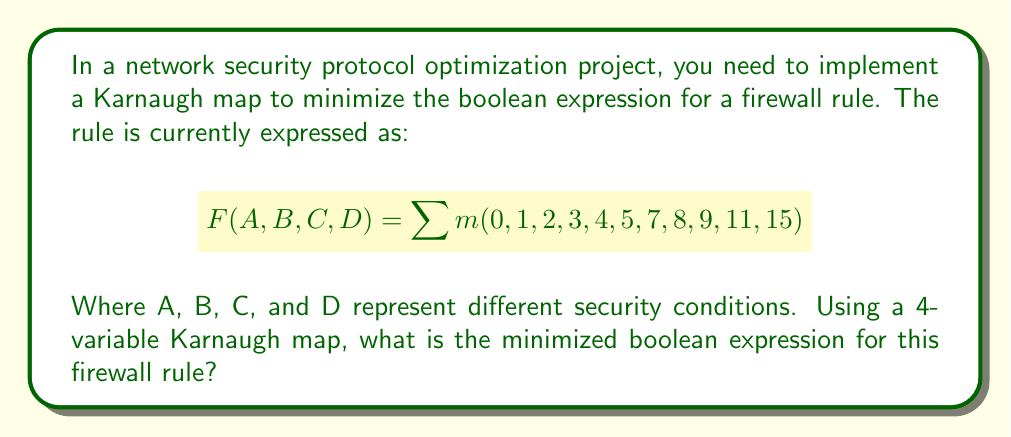Provide a solution to this math problem. Let's approach this step-by-step:

1) First, we need to create a 4-variable Karnaugh map:

[asy]
unitsize(1cm);
for(int i=0; i<4; ++i)
  for(int j=0; j<4; ++j)
    draw((i,j)--(i+1,j)--(i+1,j+1)--(i,j+1)--cycle);
label("00", (-0.5,3.5));
label("01", (-0.5,2.5));
label("11", (-0.5,1.5));
label("10", (-0.5,0.5));
label("00", (0.5,4.5));
label("01", (1.5,4.5));
label("11", (2.5,4.5));
label("10", (3.5,4.5));
[/asy]

2) Now, we fill in the 1's for the given minterms:

[asy]
unitsize(1cm);
for(int i=0; i<4; ++i)
  for(int j=0; j<4; ++j)
    draw((i,j)--(i+1,j)--(i+1,j+1)--(i,j+1)--cycle);
label("00", (-0.5,3.5));
label("01", (-0.5,2.5));
label("11", (-0.5,1.5));
label("10", (-0.5,0.5));
label("00", (0.5,4.5));
label("01", (1.5,4.5));
label("11", (2.5,4.5));
label("10", (3.5,4.5));
label("1", (0.5,3.5));
label("1", (1.5,3.5));
label("1", (0.5,2.5));
label("1", (1.5,2.5));
label("1", (0.5,1.5));
label("1", (0.5,0.5));
label("1", (1.5,0.5));
label("1", (2.5,0.5));
label("1", (3.5,3.5));
label("1", (3.5,1.5));
label("1", (3.5,0.5));
[/asy]

3) We can identify the following groups:
   - A group of 4: $\overline{A}\overline{B}$ (top-left corner)
   - A group of 4: $\overline{A}D$ (left column)
   - A group of 2: $BD$ (bottom-right corner)

4) These groups translate to the following terms:
   - $\overline{A}\overline{B}$
   - $\overline{A}D$
   - $BD$

5) The minimized expression is the OR of these terms:

$$ F(A,B,C,D) = \overline{A}\overline{B} + \overline{A}D + BD $$

This expression represents the simplified firewall rule, reducing the complexity of the original sum-of-minterms form.
Answer: $\overline{A}\overline{B} + \overline{A}D + BD$ 